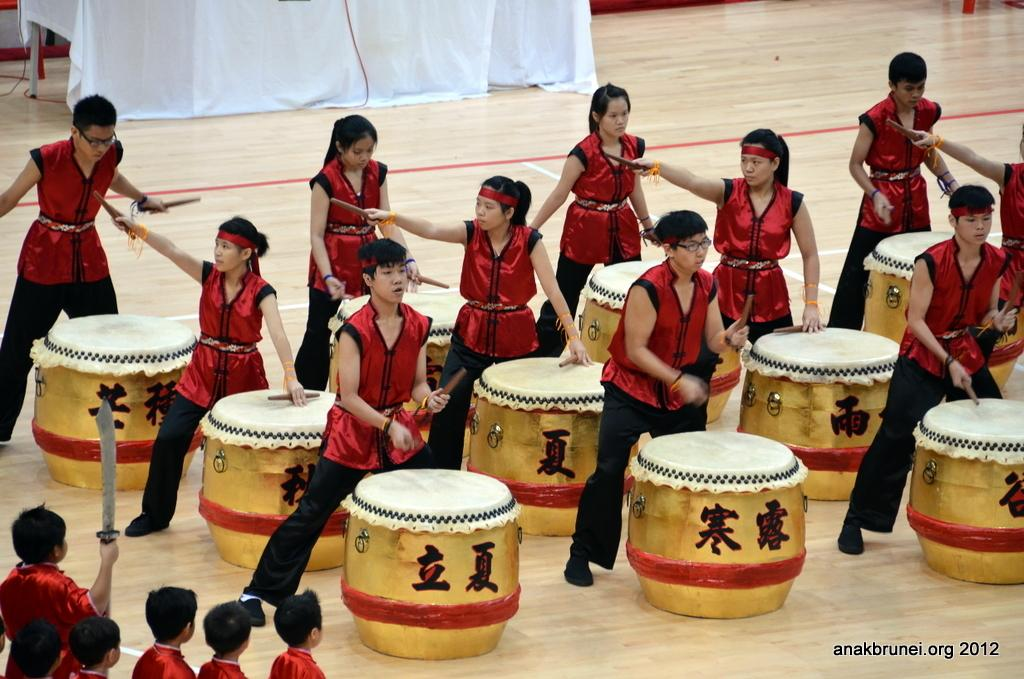What are the people in the image doing? The people in the image are standing and playing drums. Can you describe the children in the image? There are children standing in the bottom left corner of the image. What can be seen hanging in the background of the image? There is a white cloth hanging in the background of the image. How many memories are being created by the children in the image? The concept of "memories" is not present in the image, as it is an abstract concept and not a physical object or action that can be observed. 